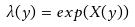Convert formula to latex. <formula><loc_0><loc_0><loc_500><loc_500>\lambda ( y ) = e x p ( X ( y ) )</formula> 